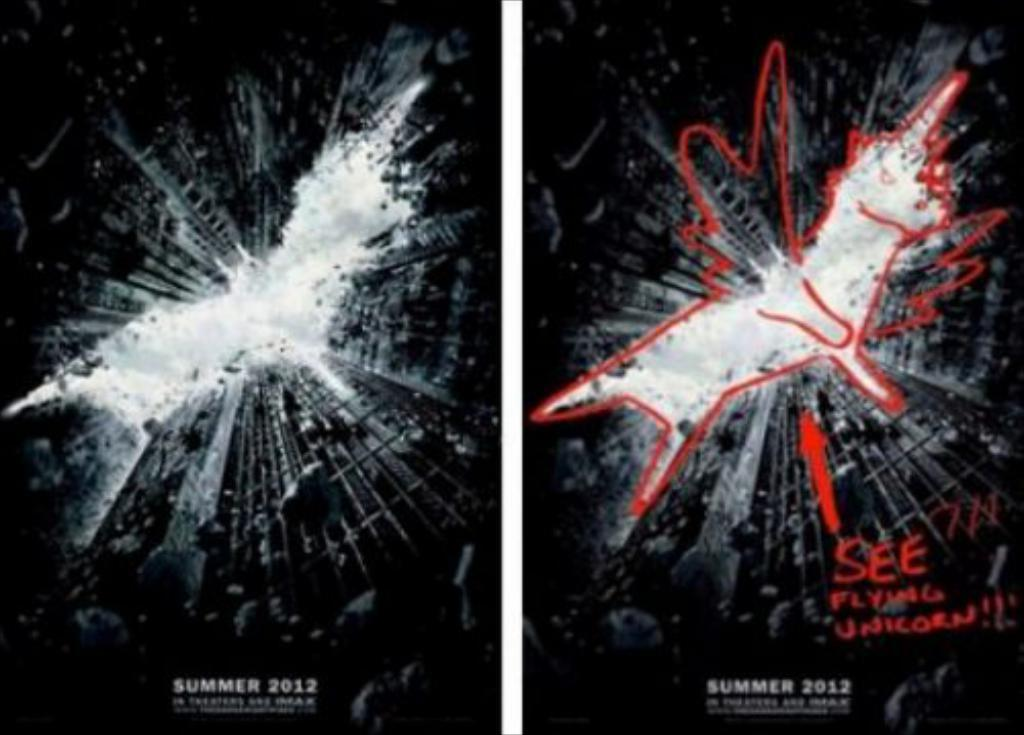Provide a one-sentence caption for the provided image. A batman movie poster has a sketch of a flying unicorn drawn on it. 